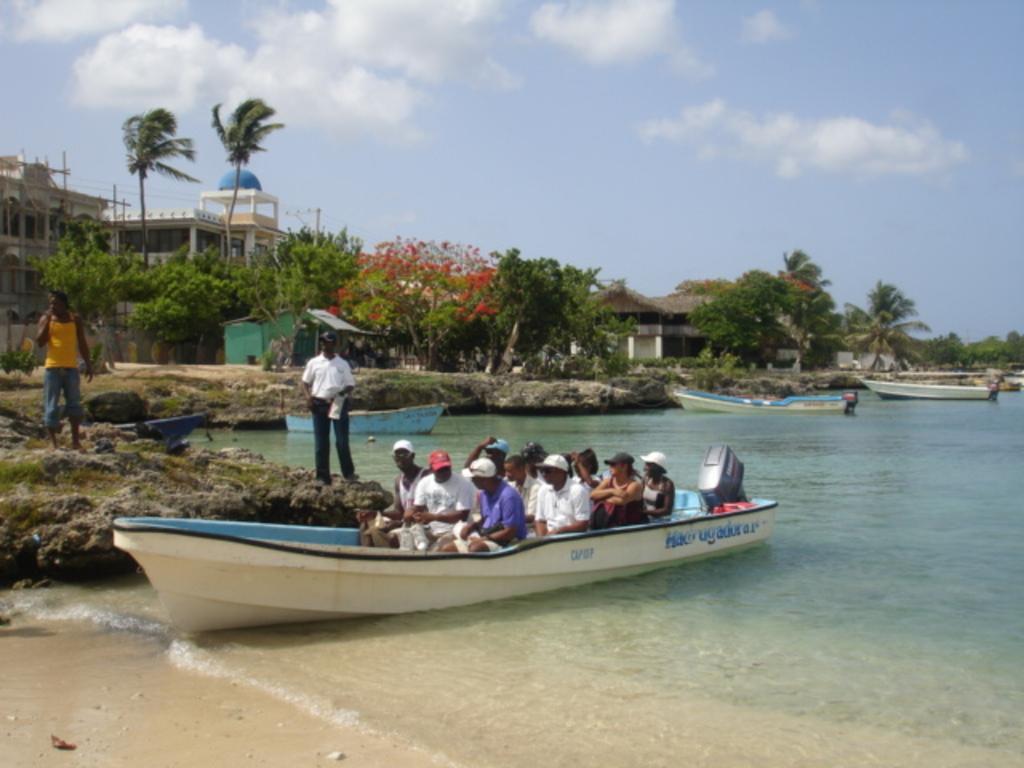How would you summarize this image in a sentence or two? In this picture, we can see a few people, a few in a boat, we can see water, boats, ground with grass, trees, plants, buildings, and the sky with clouds. 